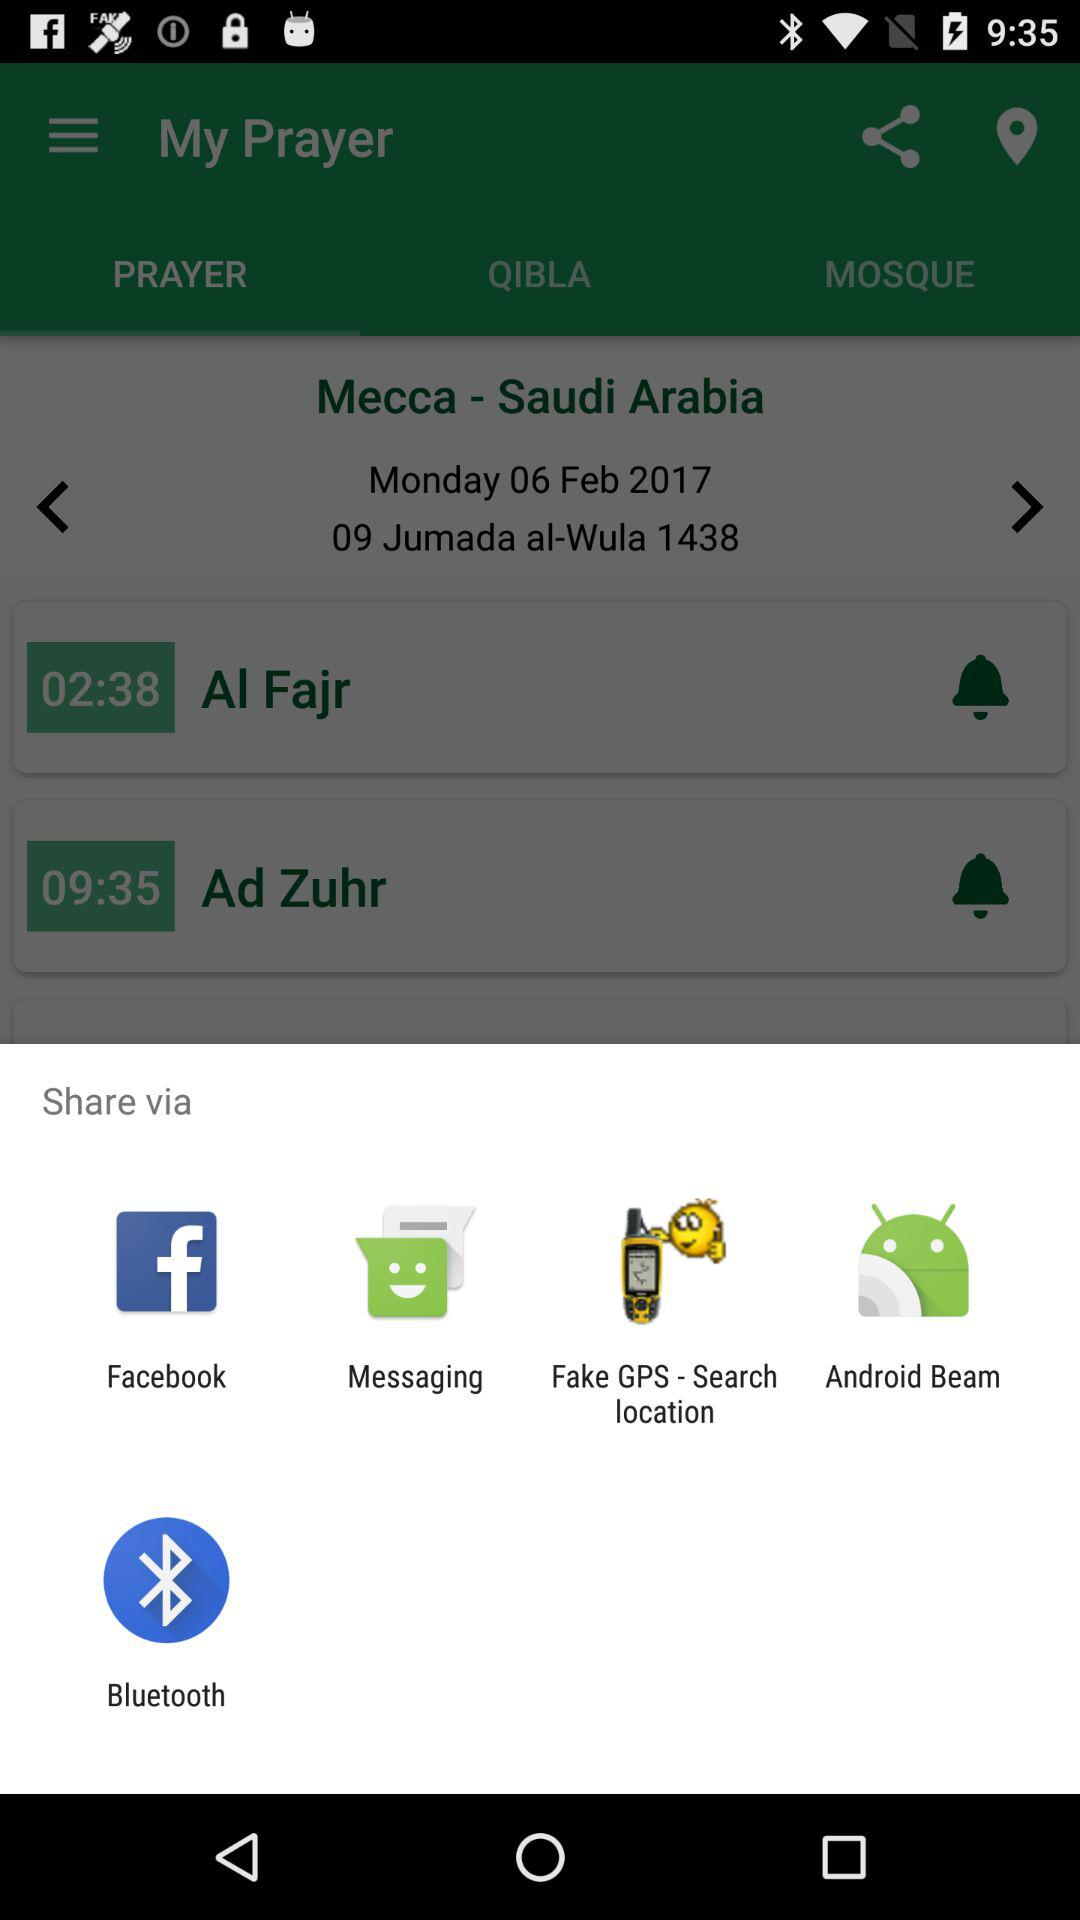Which options are given to share with? The given options to share with are "Facebook", "Messaging", "Fake GPS - Search location", "Android Beam" and "Bluetooth". 